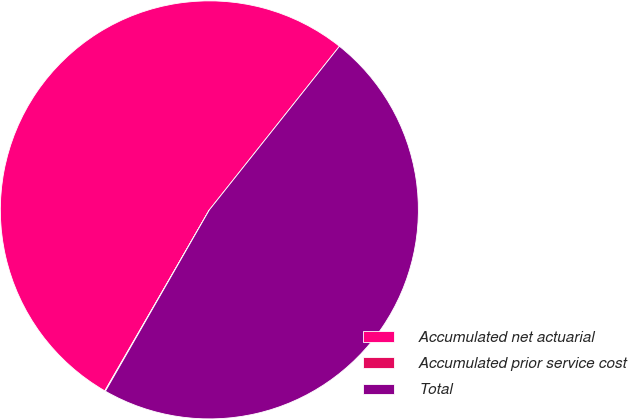<chart> <loc_0><loc_0><loc_500><loc_500><pie_chart><fcel>Accumulated net actuarial<fcel>Accumulated prior service cost<fcel>Total<nl><fcel>52.36%<fcel>0.05%<fcel>47.6%<nl></chart> 